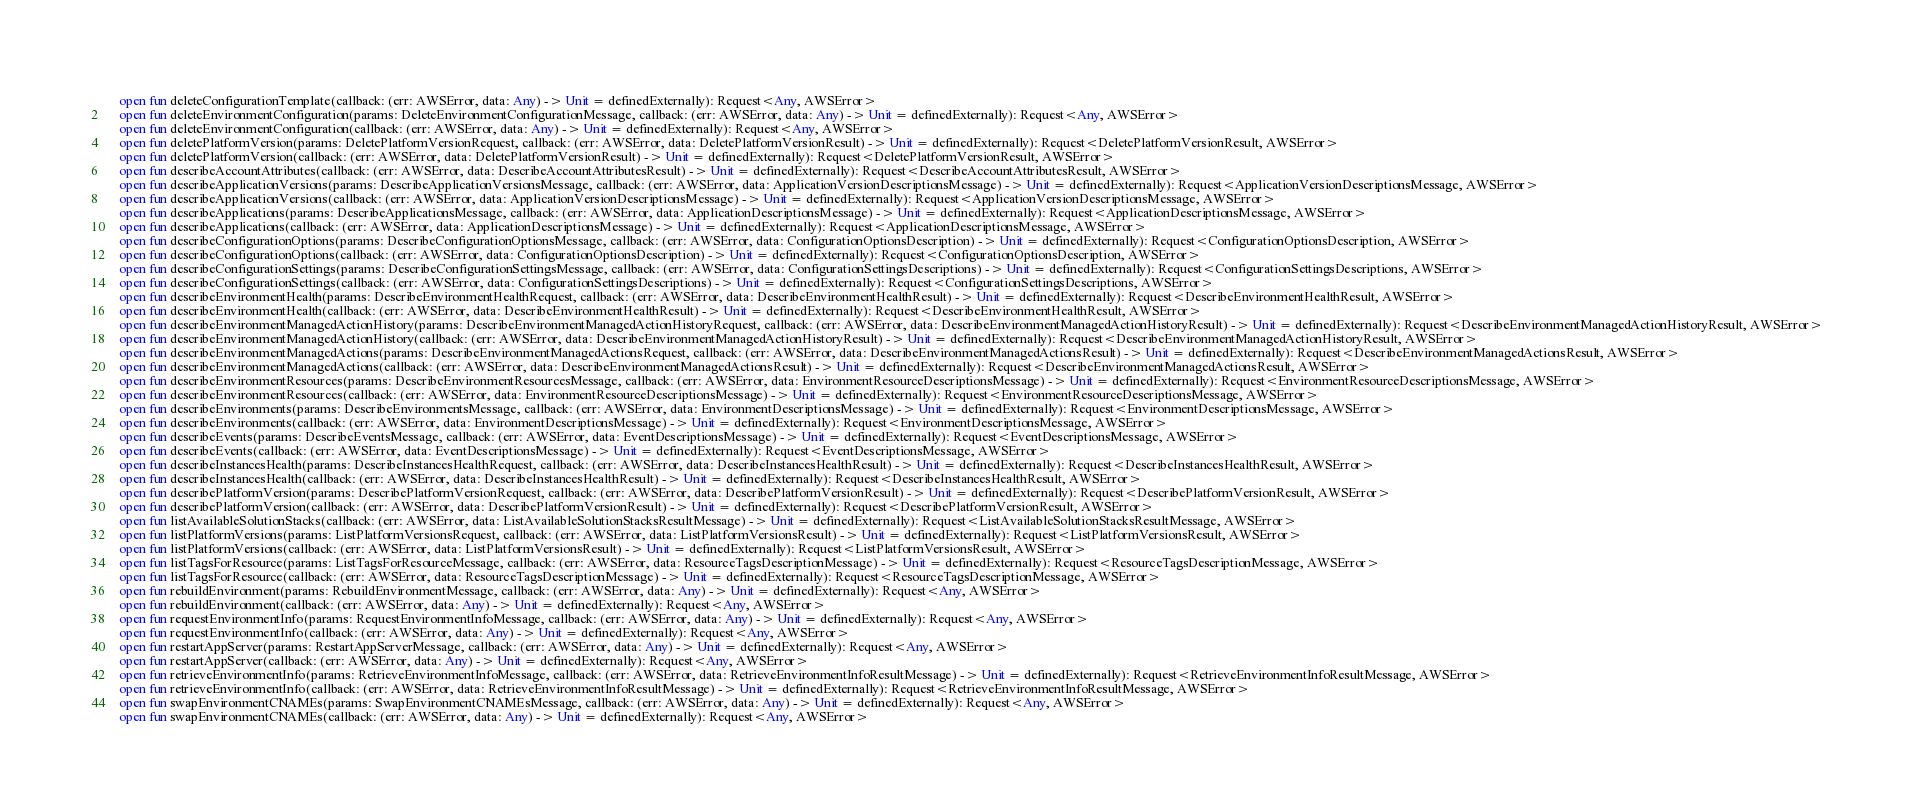<code> <loc_0><loc_0><loc_500><loc_500><_Kotlin_>    open fun deleteConfigurationTemplate(callback: (err: AWSError, data: Any) -> Unit = definedExternally): Request<Any, AWSError>
    open fun deleteEnvironmentConfiguration(params: DeleteEnvironmentConfigurationMessage, callback: (err: AWSError, data: Any) -> Unit = definedExternally): Request<Any, AWSError>
    open fun deleteEnvironmentConfiguration(callback: (err: AWSError, data: Any) -> Unit = definedExternally): Request<Any, AWSError>
    open fun deletePlatformVersion(params: DeletePlatformVersionRequest, callback: (err: AWSError, data: DeletePlatformVersionResult) -> Unit = definedExternally): Request<DeletePlatformVersionResult, AWSError>
    open fun deletePlatformVersion(callback: (err: AWSError, data: DeletePlatformVersionResult) -> Unit = definedExternally): Request<DeletePlatformVersionResult, AWSError>
    open fun describeAccountAttributes(callback: (err: AWSError, data: DescribeAccountAttributesResult) -> Unit = definedExternally): Request<DescribeAccountAttributesResult, AWSError>
    open fun describeApplicationVersions(params: DescribeApplicationVersionsMessage, callback: (err: AWSError, data: ApplicationVersionDescriptionsMessage) -> Unit = definedExternally): Request<ApplicationVersionDescriptionsMessage, AWSError>
    open fun describeApplicationVersions(callback: (err: AWSError, data: ApplicationVersionDescriptionsMessage) -> Unit = definedExternally): Request<ApplicationVersionDescriptionsMessage, AWSError>
    open fun describeApplications(params: DescribeApplicationsMessage, callback: (err: AWSError, data: ApplicationDescriptionsMessage) -> Unit = definedExternally): Request<ApplicationDescriptionsMessage, AWSError>
    open fun describeApplications(callback: (err: AWSError, data: ApplicationDescriptionsMessage) -> Unit = definedExternally): Request<ApplicationDescriptionsMessage, AWSError>
    open fun describeConfigurationOptions(params: DescribeConfigurationOptionsMessage, callback: (err: AWSError, data: ConfigurationOptionsDescription) -> Unit = definedExternally): Request<ConfigurationOptionsDescription, AWSError>
    open fun describeConfigurationOptions(callback: (err: AWSError, data: ConfigurationOptionsDescription) -> Unit = definedExternally): Request<ConfigurationOptionsDescription, AWSError>
    open fun describeConfigurationSettings(params: DescribeConfigurationSettingsMessage, callback: (err: AWSError, data: ConfigurationSettingsDescriptions) -> Unit = definedExternally): Request<ConfigurationSettingsDescriptions, AWSError>
    open fun describeConfigurationSettings(callback: (err: AWSError, data: ConfigurationSettingsDescriptions) -> Unit = definedExternally): Request<ConfigurationSettingsDescriptions, AWSError>
    open fun describeEnvironmentHealth(params: DescribeEnvironmentHealthRequest, callback: (err: AWSError, data: DescribeEnvironmentHealthResult) -> Unit = definedExternally): Request<DescribeEnvironmentHealthResult, AWSError>
    open fun describeEnvironmentHealth(callback: (err: AWSError, data: DescribeEnvironmentHealthResult) -> Unit = definedExternally): Request<DescribeEnvironmentHealthResult, AWSError>
    open fun describeEnvironmentManagedActionHistory(params: DescribeEnvironmentManagedActionHistoryRequest, callback: (err: AWSError, data: DescribeEnvironmentManagedActionHistoryResult) -> Unit = definedExternally): Request<DescribeEnvironmentManagedActionHistoryResult, AWSError>
    open fun describeEnvironmentManagedActionHistory(callback: (err: AWSError, data: DescribeEnvironmentManagedActionHistoryResult) -> Unit = definedExternally): Request<DescribeEnvironmentManagedActionHistoryResult, AWSError>
    open fun describeEnvironmentManagedActions(params: DescribeEnvironmentManagedActionsRequest, callback: (err: AWSError, data: DescribeEnvironmentManagedActionsResult) -> Unit = definedExternally): Request<DescribeEnvironmentManagedActionsResult, AWSError>
    open fun describeEnvironmentManagedActions(callback: (err: AWSError, data: DescribeEnvironmentManagedActionsResult) -> Unit = definedExternally): Request<DescribeEnvironmentManagedActionsResult, AWSError>
    open fun describeEnvironmentResources(params: DescribeEnvironmentResourcesMessage, callback: (err: AWSError, data: EnvironmentResourceDescriptionsMessage) -> Unit = definedExternally): Request<EnvironmentResourceDescriptionsMessage, AWSError>
    open fun describeEnvironmentResources(callback: (err: AWSError, data: EnvironmentResourceDescriptionsMessage) -> Unit = definedExternally): Request<EnvironmentResourceDescriptionsMessage, AWSError>
    open fun describeEnvironments(params: DescribeEnvironmentsMessage, callback: (err: AWSError, data: EnvironmentDescriptionsMessage) -> Unit = definedExternally): Request<EnvironmentDescriptionsMessage, AWSError>
    open fun describeEnvironments(callback: (err: AWSError, data: EnvironmentDescriptionsMessage) -> Unit = definedExternally): Request<EnvironmentDescriptionsMessage, AWSError>
    open fun describeEvents(params: DescribeEventsMessage, callback: (err: AWSError, data: EventDescriptionsMessage) -> Unit = definedExternally): Request<EventDescriptionsMessage, AWSError>
    open fun describeEvents(callback: (err: AWSError, data: EventDescriptionsMessage) -> Unit = definedExternally): Request<EventDescriptionsMessage, AWSError>
    open fun describeInstancesHealth(params: DescribeInstancesHealthRequest, callback: (err: AWSError, data: DescribeInstancesHealthResult) -> Unit = definedExternally): Request<DescribeInstancesHealthResult, AWSError>
    open fun describeInstancesHealth(callback: (err: AWSError, data: DescribeInstancesHealthResult) -> Unit = definedExternally): Request<DescribeInstancesHealthResult, AWSError>
    open fun describePlatformVersion(params: DescribePlatformVersionRequest, callback: (err: AWSError, data: DescribePlatformVersionResult) -> Unit = definedExternally): Request<DescribePlatformVersionResult, AWSError>
    open fun describePlatformVersion(callback: (err: AWSError, data: DescribePlatformVersionResult) -> Unit = definedExternally): Request<DescribePlatformVersionResult, AWSError>
    open fun listAvailableSolutionStacks(callback: (err: AWSError, data: ListAvailableSolutionStacksResultMessage) -> Unit = definedExternally): Request<ListAvailableSolutionStacksResultMessage, AWSError>
    open fun listPlatformVersions(params: ListPlatformVersionsRequest, callback: (err: AWSError, data: ListPlatformVersionsResult) -> Unit = definedExternally): Request<ListPlatformVersionsResult, AWSError>
    open fun listPlatformVersions(callback: (err: AWSError, data: ListPlatformVersionsResult) -> Unit = definedExternally): Request<ListPlatformVersionsResult, AWSError>
    open fun listTagsForResource(params: ListTagsForResourceMessage, callback: (err: AWSError, data: ResourceTagsDescriptionMessage) -> Unit = definedExternally): Request<ResourceTagsDescriptionMessage, AWSError>
    open fun listTagsForResource(callback: (err: AWSError, data: ResourceTagsDescriptionMessage) -> Unit = definedExternally): Request<ResourceTagsDescriptionMessage, AWSError>
    open fun rebuildEnvironment(params: RebuildEnvironmentMessage, callback: (err: AWSError, data: Any) -> Unit = definedExternally): Request<Any, AWSError>
    open fun rebuildEnvironment(callback: (err: AWSError, data: Any) -> Unit = definedExternally): Request<Any, AWSError>
    open fun requestEnvironmentInfo(params: RequestEnvironmentInfoMessage, callback: (err: AWSError, data: Any) -> Unit = definedExternally): Request<Any, AWSError>
    open fun requestEnvironmentInfo(callback: (err: AWSError, data: Any) -> Unit = definedExternally): Request<Any, AWSError>
    open fun restartAppServer(params: RestartAppServerMessage, callback: (err: AWSError, data: Any) -> Unit = definedExternally): Request<Any, AWSError>
    open fun restartAppServer(callback: (err: AWSError, data: Any) -> Unit = definedExternally): Request<Any, AWSError>
    open fun retrieveEnvironmentInfo(params: RetrieveEnvironmentInfoMessage, callback: (err: AWSError, data: RetrieveEnvironmentInfoResultMessage) -> Unit = definedExternally): Request<RetrieveEnvironmentInfoResultMessage, AWSError>
    open fun retrieveEnvironmentInfo(callback: (err: AWSError, data: RetrieveEnvironmentInfoResultMessage) -> Unit = definedExternally): Request<RetrieveEnvironmentInfoResultMessage, AWSError>
    open fun swapEnvironmentCNAMEs(params: SwapEnvironmentCNAMEsMessage, callback: (err: AWSError, data: Any) -> Unit = definedExternally): Request<Any, AWSError>
    open fun swapEnvironmentCNAMEs(callback: (err: AWSError, data: Any) -> Unit = definedExternally): Request<Any, AWSError></code> 